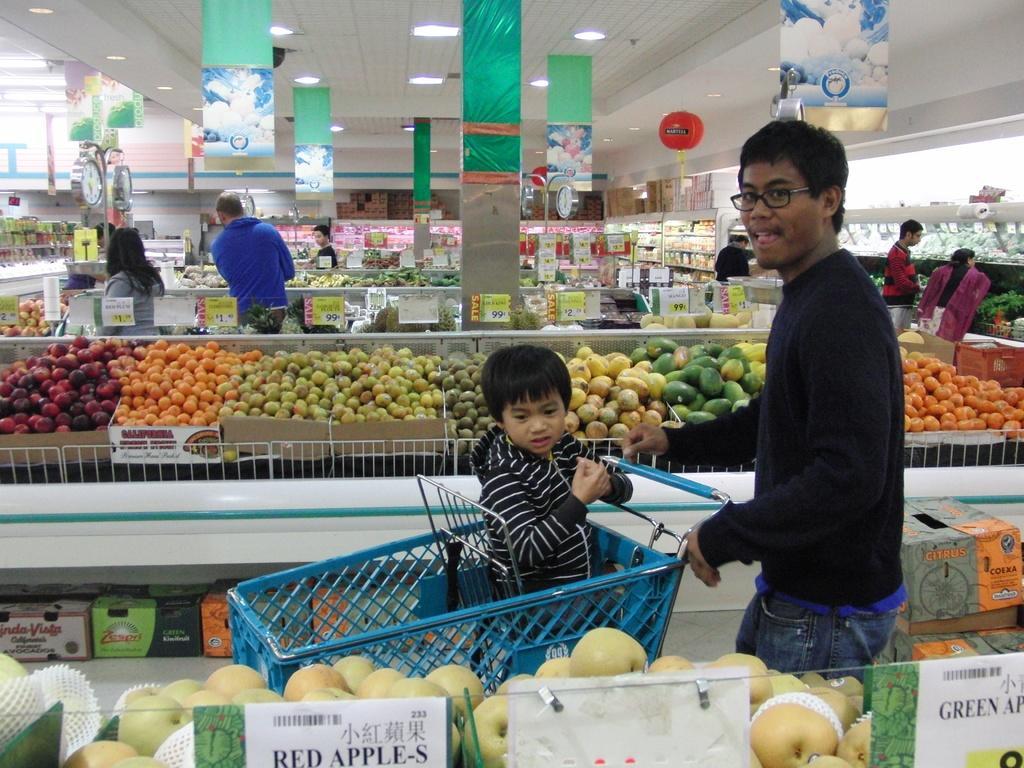How would you summarize this image in a sentence or two? In this picture we can see there are groups of people inside the building. A kid is sitting in a shopping cart. Behind the kid there are some foods, price boards, pillars, banners and some objects. At the top there are ceiling lights. 